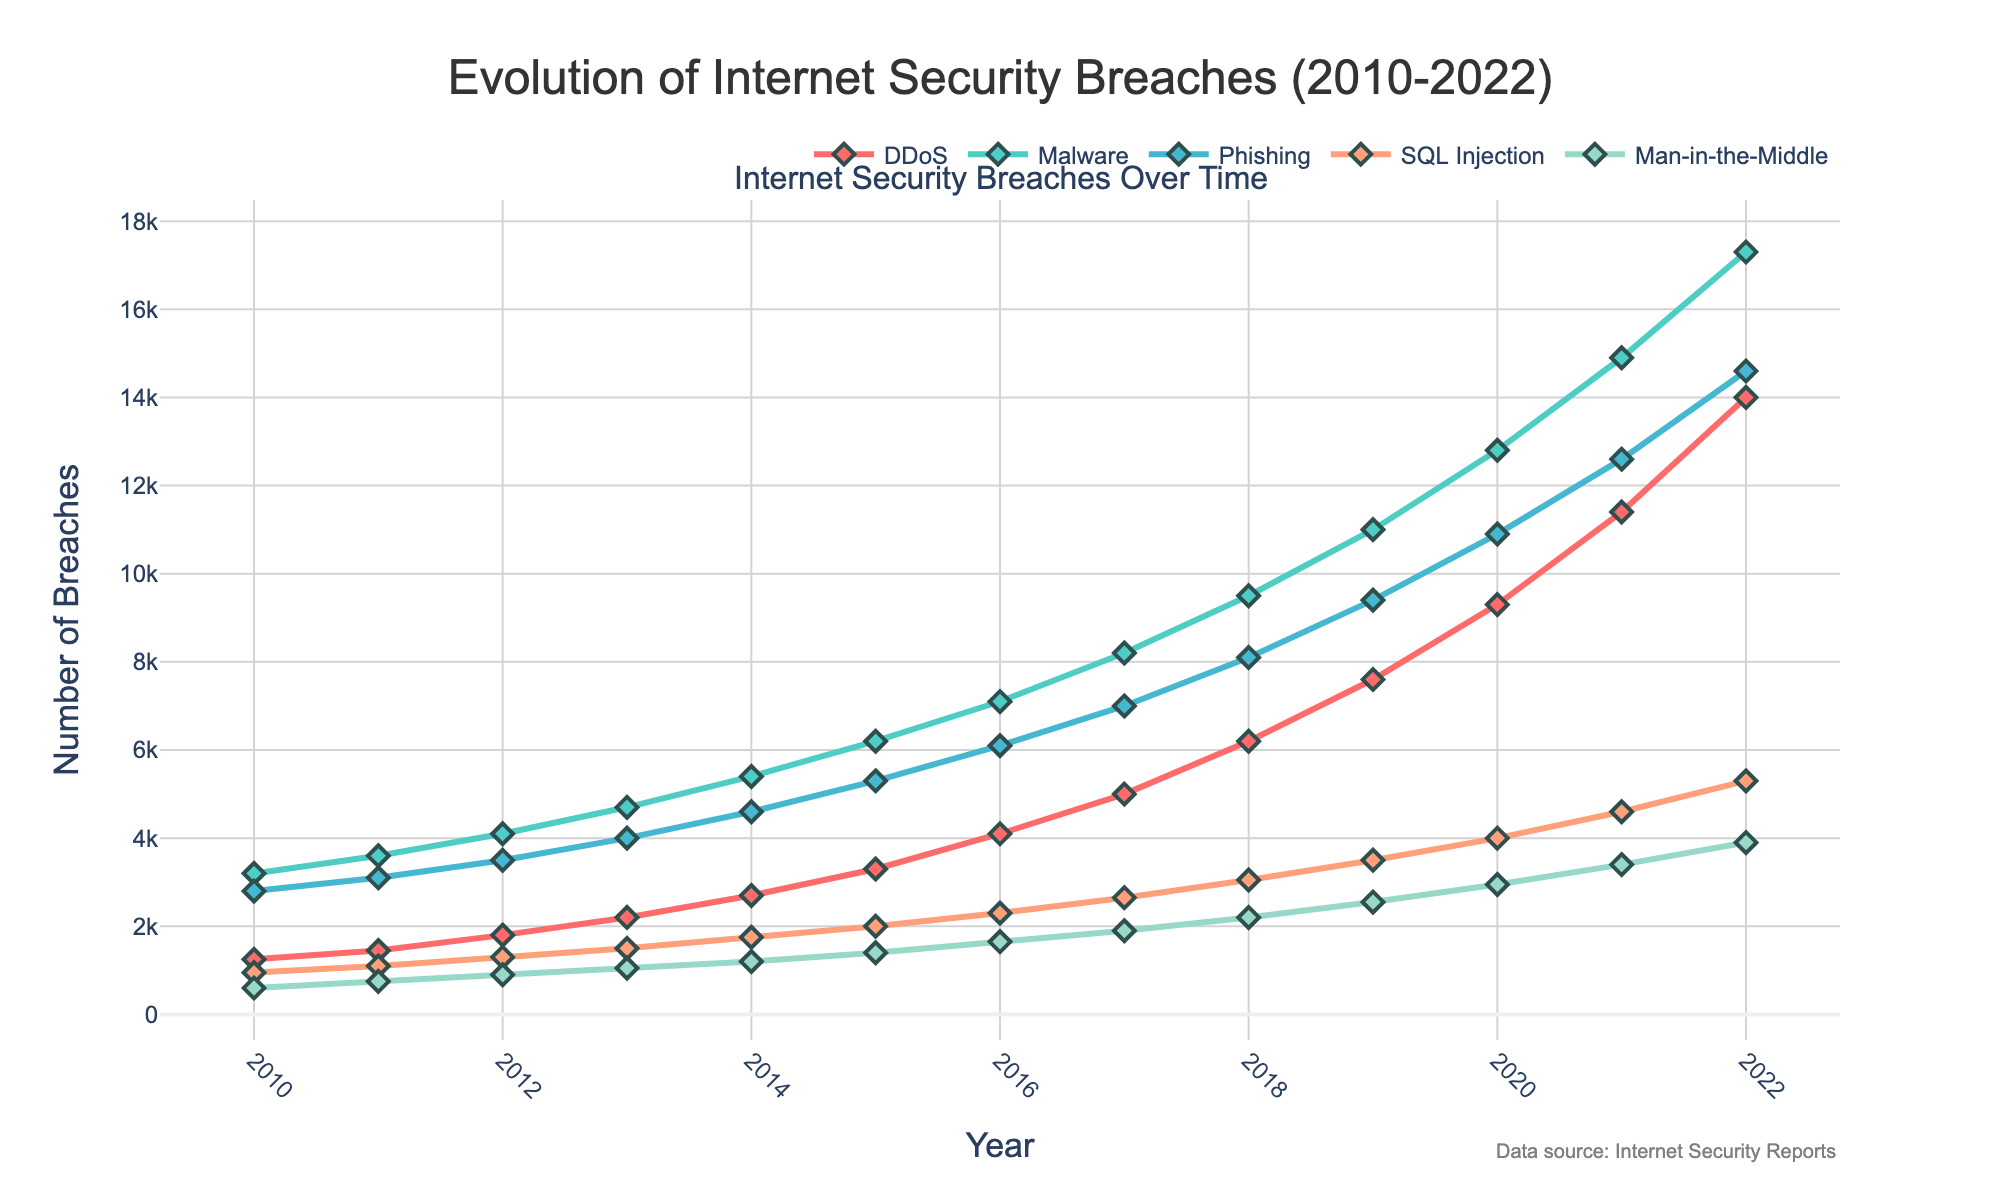Which type of attack had the highest number of breaches in 2022? By looking at the endpoint of each line in the graph at the year 2022, the line representing Malware has the highest endpoint.
Answer: Malware Which attack type saw the largest increase in breaches from 2010 to 2022? Calculate the difference between the number of breaches in 2022 and 2010 for each attack type, and compare these values.
Answer: DDoS How did the number of SQL Injection breaches change from 2015 to 2020? Observe the SQL Injection line between the years 2015 and 2020 and note the trend. There is an increasing trend from 2000 in 2015 to 4000 in 2020.
Answer: Increased Compare the trends of Phishing and Man-in-the-Middle attacks over time. Which had a steeper increase? By checking the steepness of the lines for Phishing and Man-in-the-Middle overall, the Phishing line appears steeper.
Answer: Phishing What is the average number of breaches for DDoS attacks between 2010 and 2022? Sum the number of breaches for DDoS attacks from each year and divide by the total number of years (13). (1250+1450+1800+2200+2700+3300+4100+5000+6200+7600+9300+11400+14000) / 13 = 5692.3
Answer: 5692.3 Which year experienced the highest number of breaches across all types of attacks? Sum up the breaches for each attack type per year and identify the year with the highest total. 2022 had the highest total with 14000+17300+14600+5300+3900=55100 breaches.
Answer: 2022 What is the ratio of Malware breaches to DDoS breaches in 2019? Divide the number of Malware breaches by the number of DDoS breaches in 2019. 11000/7600 ≈ 1.45
Answer: 1.45 In which year did Phishing attacks surpass 8000 breaches? Look for the point on the Phishing line that first goes above 8000. This happens in 2018.
Answer: 2018 